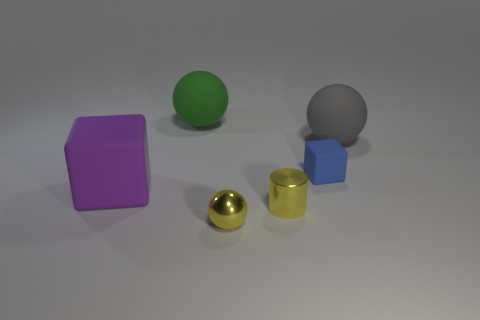Are there any large gray balls made of the same material as the large purple thing?
Give a very brief answer. Yes. There is a sphere behind the gray matte sphere; are there any large matte things that are left of it?
Offer a terse response. Yes. Does the block that is left of the yellow metallic sphere have the same size as the small shiny cylinder?
Your answer should be compact. No. The blue cube is what size?
Offer a terse response. Small. Is there a small cylinder that has the same color as the tiny rubber thing?
Your response must be concise. No. What number of large things are either gray balls or yellow metallic cylinders?
Offer a very short reply. 1. How big is the object that is behind the metal cylinder and in front of the tiny blue thing?
Provide a short and direct response. Large. There is a large matte cube; what number of green matte spheres are in front of it?
Your answer should be compact. 0. The matte thing that is both in front of the gray ball and right of the big green rubber sphere has what shape?
Your answer should be compact. Cube. There is a sphere that is the same color as the tiny cylinder; what is its material?
Keep it short and to the point. Metal. 